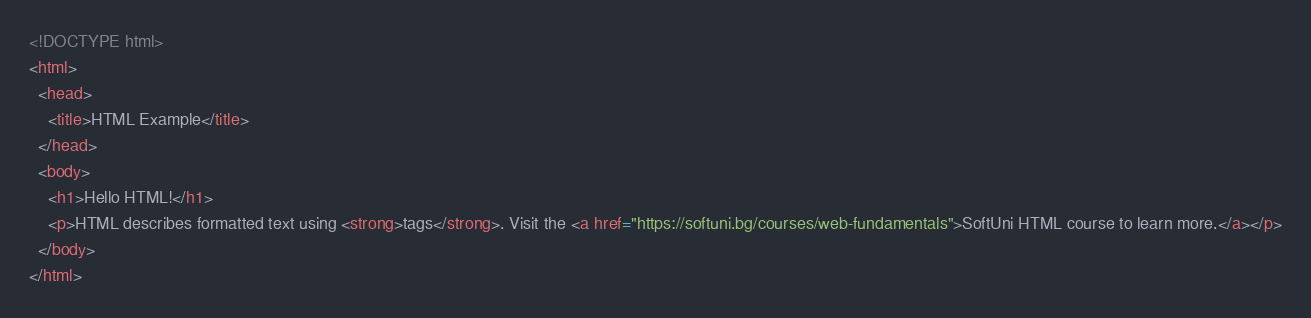<code> <loc_0><loc_0><loc_500><loc_500><_HTML_><!DOCTYPE html>
<html>
  <head>
    <title>HTML Example</title>
  </head>
  <body>
    <h1>Hello HTML!</h1>
    <p>HTML describes formatted text using <strong>tags</strong>. Visit the <a href="https://softuni.bg/courses/web-fundamentals">SoftUni HTML course to learn more.</a></p>
  </body>
</html>
</code> 